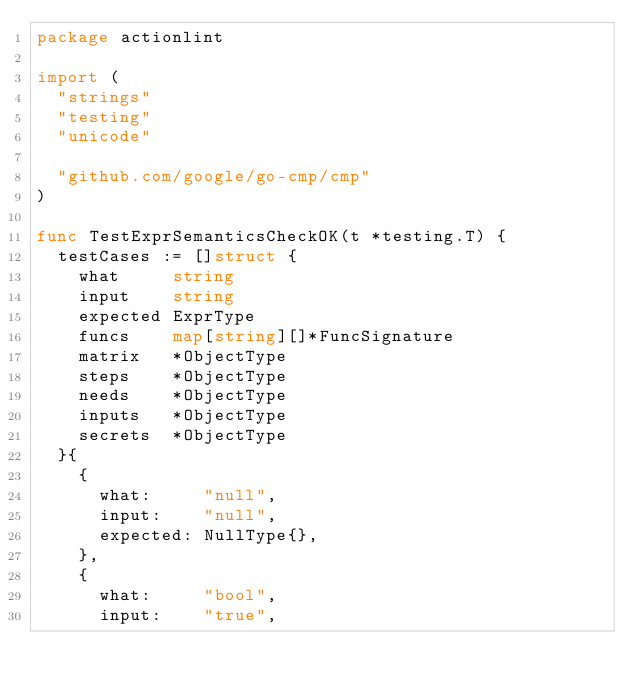Convert code to text. <code><loc_0><loc_0><loc_500><loc_500><_Go_>package actionlint

import (
	"strings"
	"testing"
	"unicode"

	"github.com/google/go-cmp/cmp"
)

func TestExprSemanticsCheckOK(t *testing.T) {
	testCases := []struct {
		what     string
		input    string
		expected ExprType
		funcs    map[string][]*FuncSignature
		matrix   *ObjectType
		steps    *ObjectType
		needs    *ObjectType
		inputs   *ObjectType
		secrets  *ObjectType
	}{
		{
			what:     "null",
			input:    "null",
			expected: NullType{},
		},
		{
			what:     "bool",
			input:    "true",</code> 